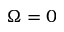Convert formula to latex. <formula><loc_0><loc_0><loc_500><loc_500>\Omega = 0</formula> 